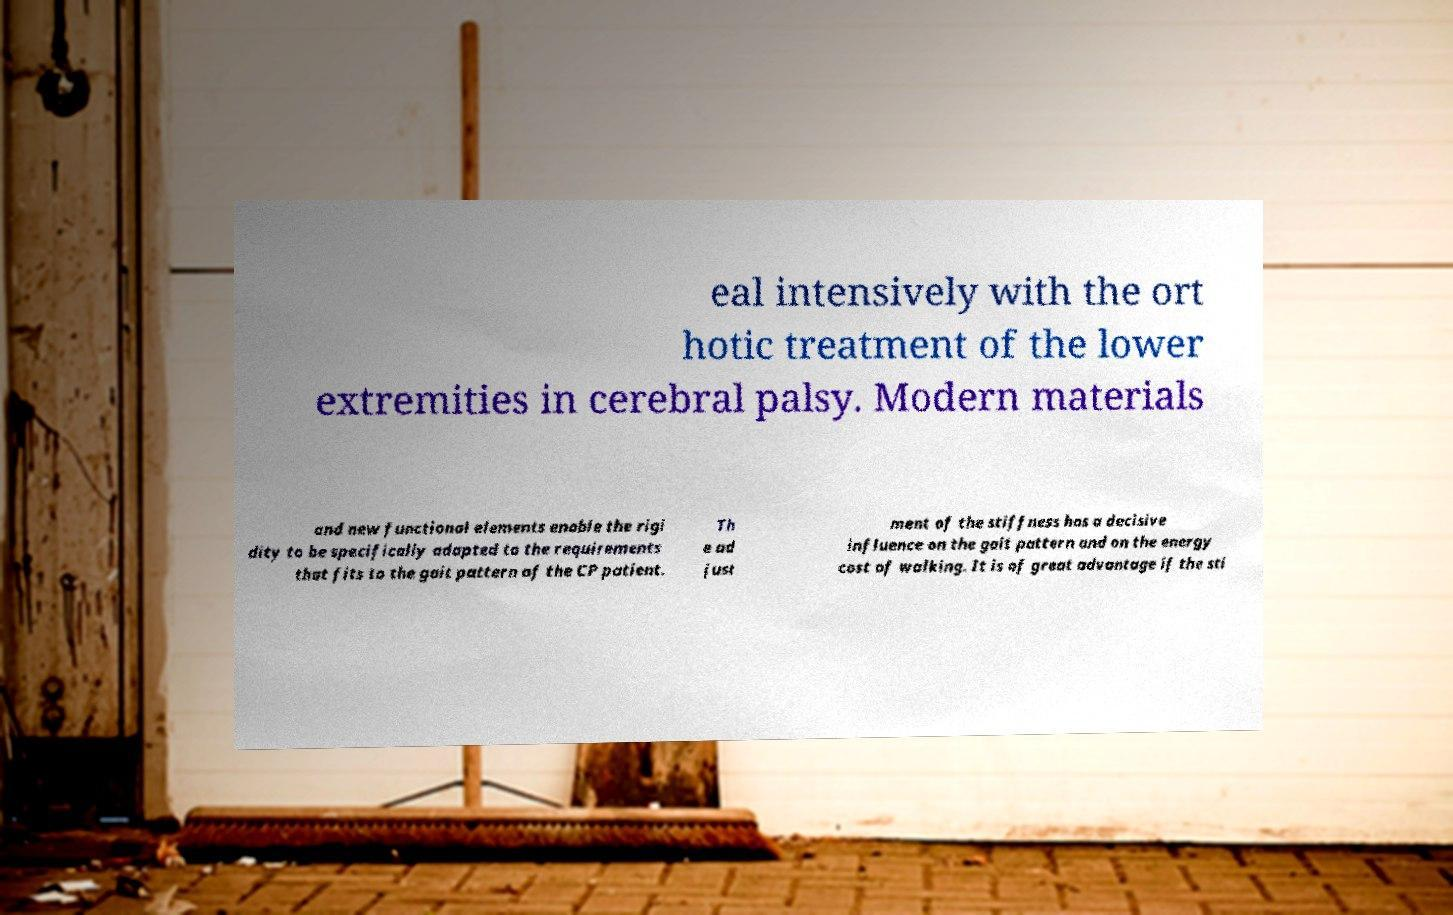Can you read and provide the text displayed in the image?This photo seems to have some interesting text. Can you extract and type it out for me? eal intensively with the ort hotic treatment of the lower extremities in cerebral palsy. Modern materials and new functional elements enable the rigi dity to be specifically adapted to the requirements that fits to the gait pattern of the CP patient. Th e ad just ment of the stiffness has a decisive influence on the gait pattern and on the energy cost of walking. It is of great advantage if the sti 